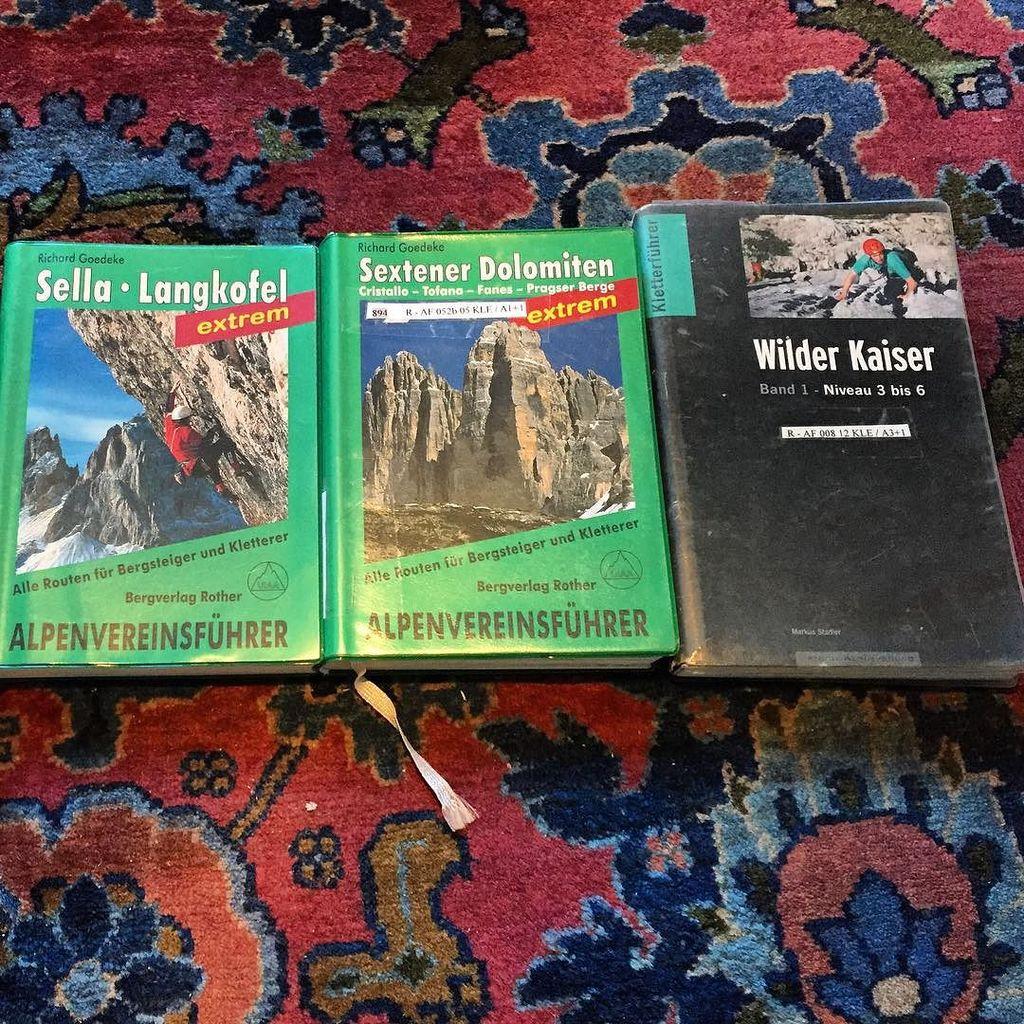What is the title of the black book?
Offer a very short reply. Wilder kaiser. What is the title of the middle book?
Give a very brief answer. Sextener dolomiten. 